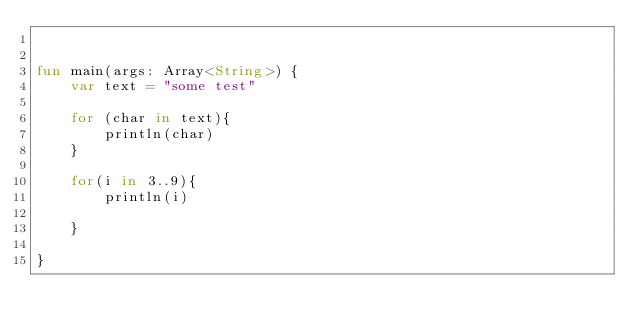<code> <loc_0><loc_0><loc_500><loc_500><_Kotlin_>

fun main(args: Array<String>) {
    var text = "some test"

    for (char in text){
        println(char)
    }

    for(i in 3..9){
        println(i)

    }

}

</code> 